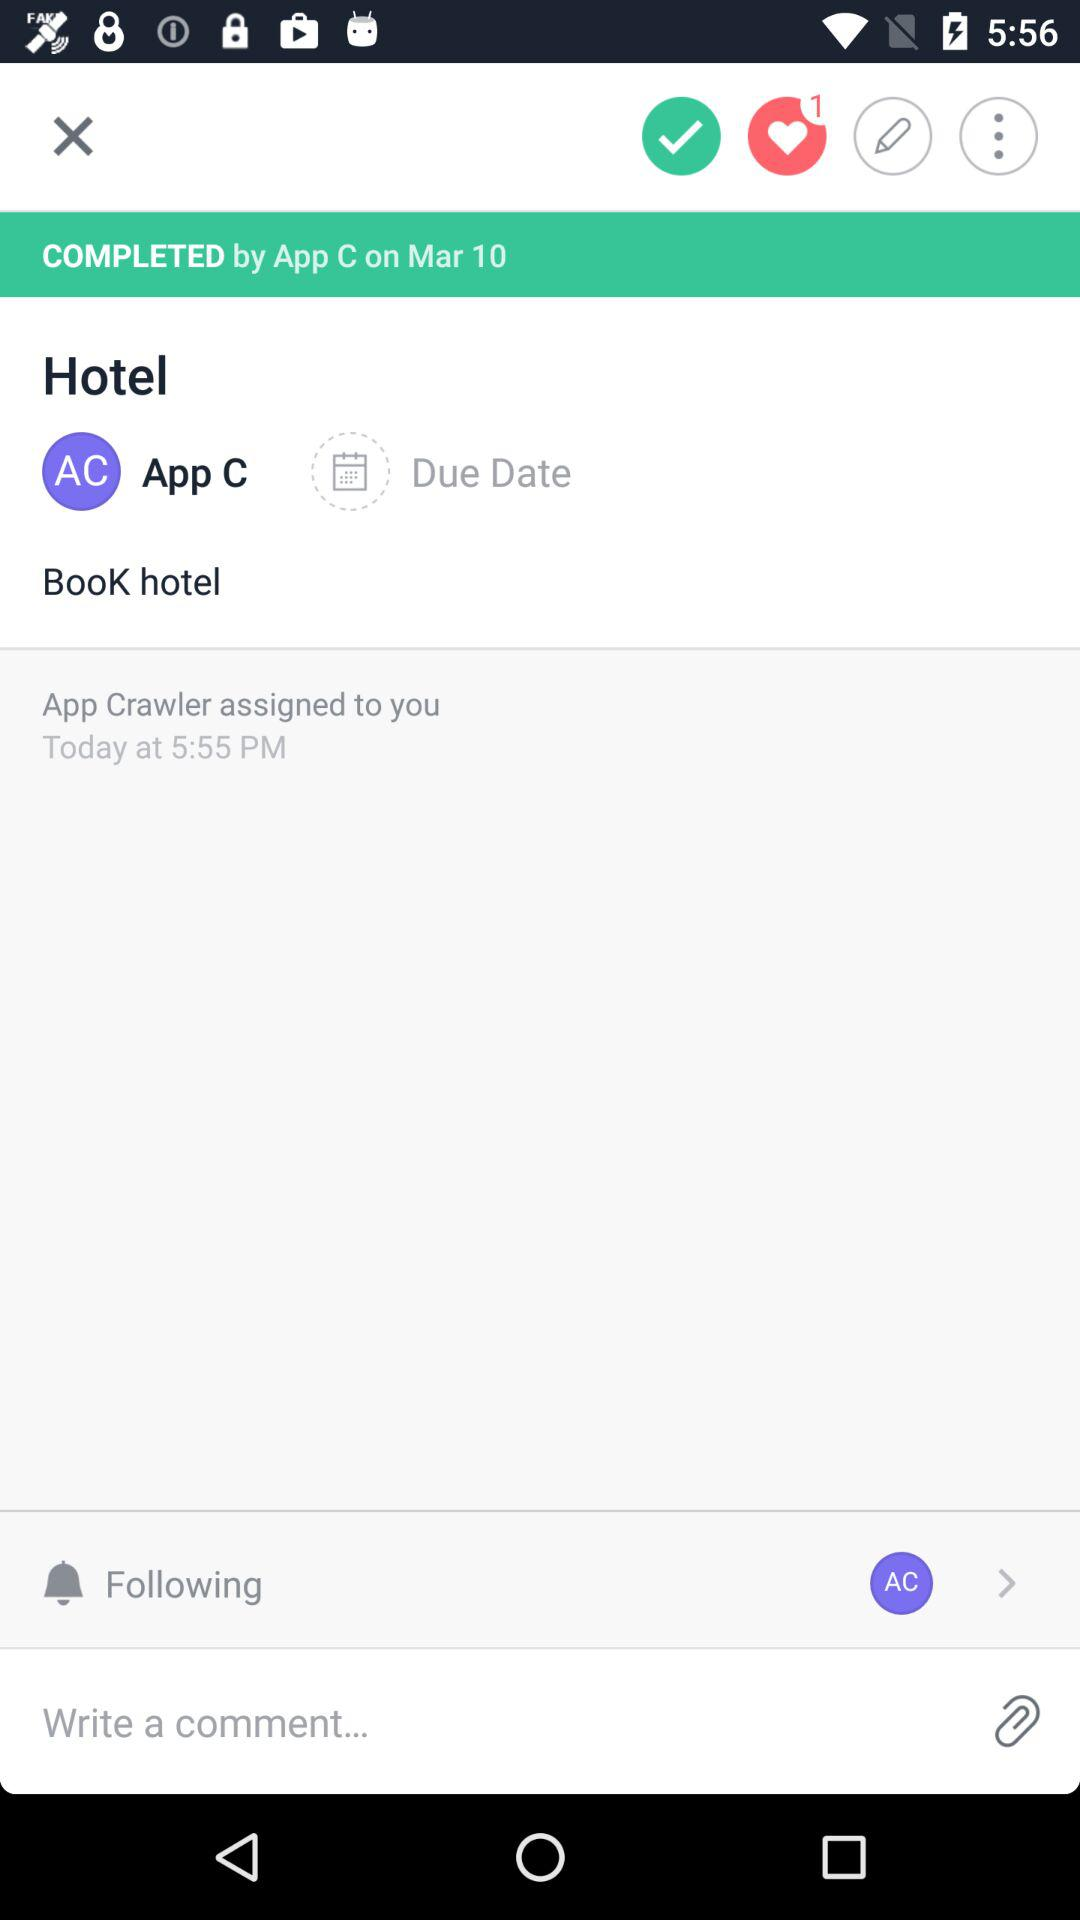How many total number of message are pending?
When the provided information is insufficient, respond with <no answer>. <no answer> 